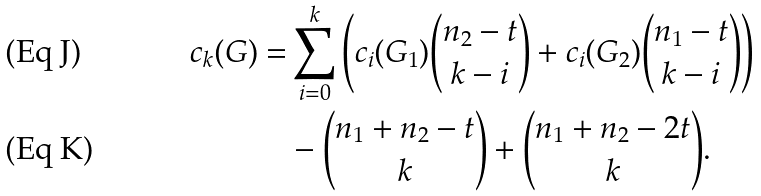Convert formula to latex. <formula><loc_0><loc_0><loc_500><loc_500>c _ { k } ( G ) = & \sum _ { i = 0 } ^ { k } \left ( c _ { i } ( G _ { 1 } ) \binom { n _ { 2 } - t } { k - i } + c _ { i } ( G _ { 2 } ) \binom { n _ { 1 } - t } { k - i } \right ) \\ & - \binom { n _ { 1 } + n _ { 2 } - t } { k } + \binom { n _ { 1 } + n _ { 2 } - 2 t } { k } .</formula> 